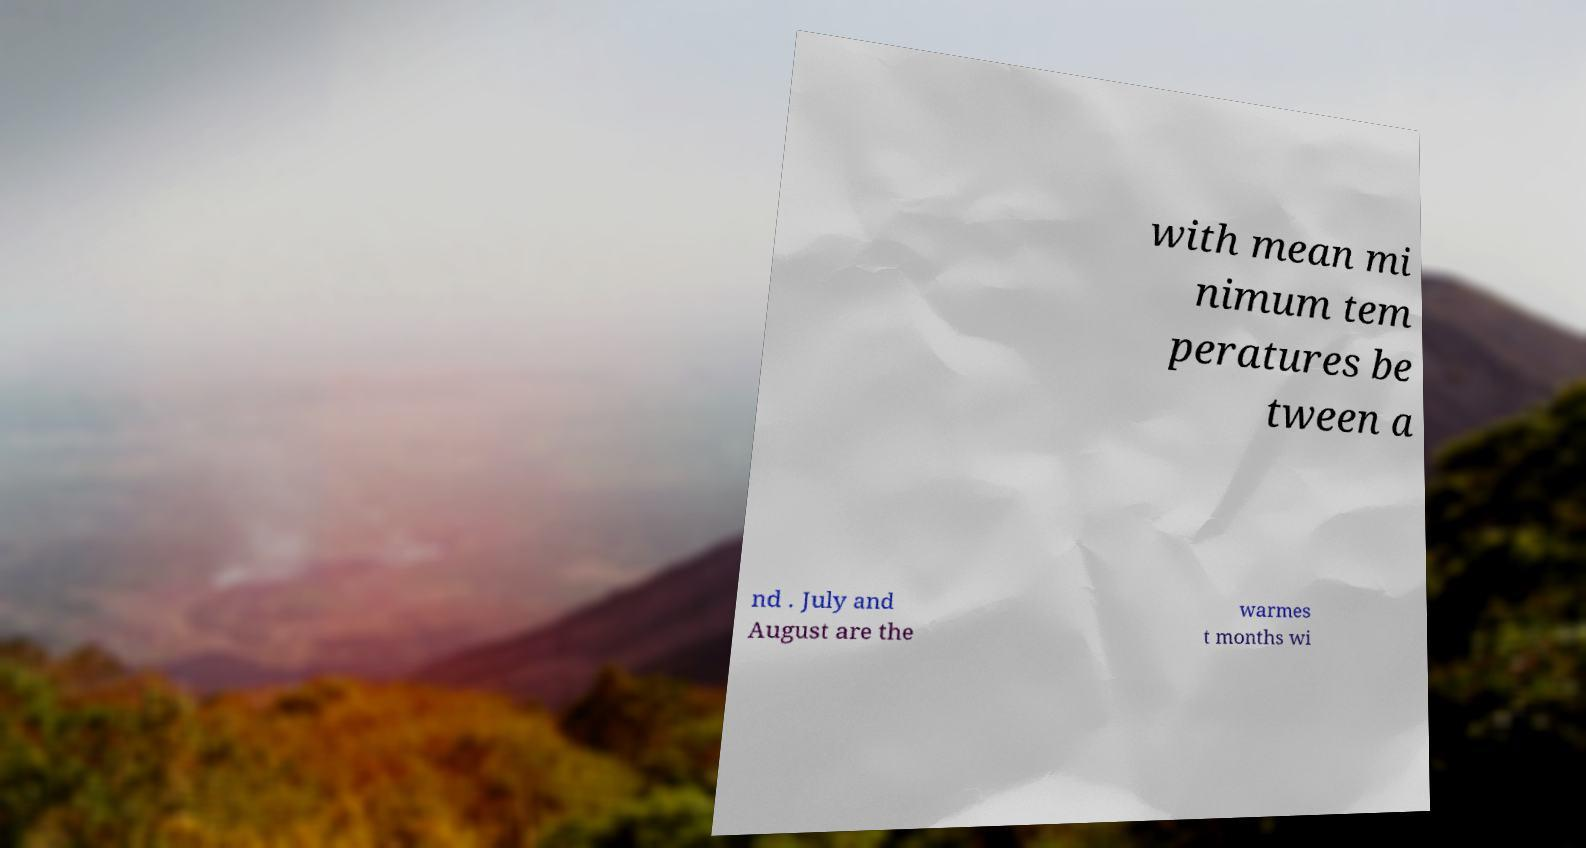Can you accurately transcribe the text from the provided image for me? with mean mi nimum tem peratures be tween a nd . July and August are the warmes t months wi 